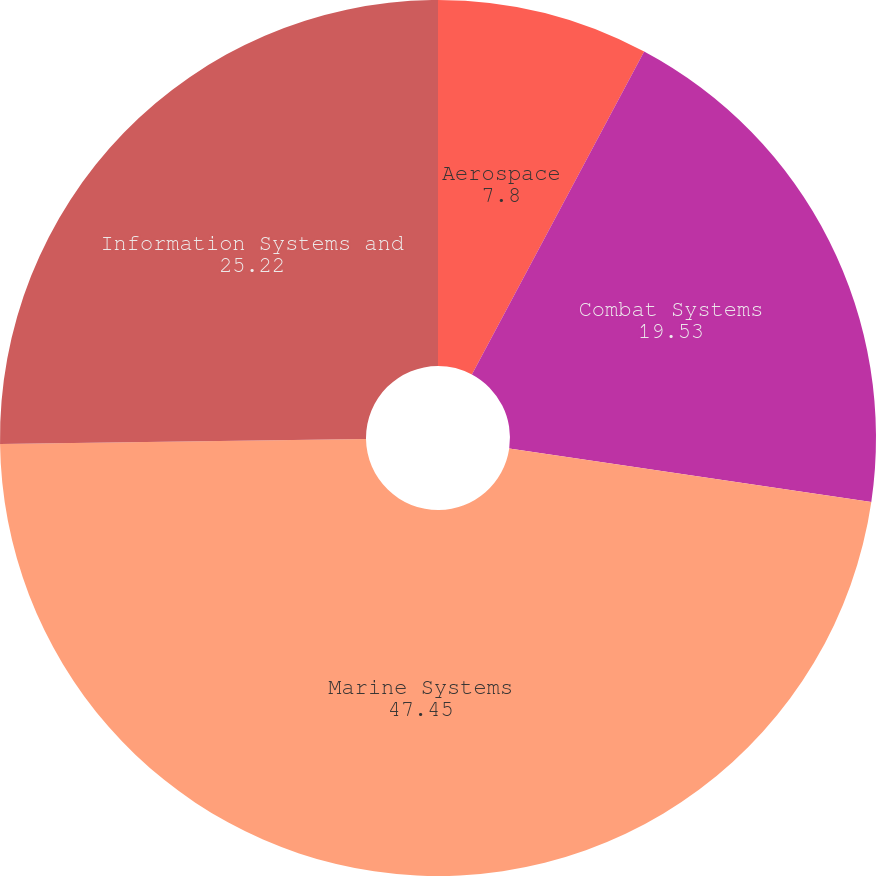Convert chart. <chart><loc_0><loc_0><loc_500><loc_500><pie_chart><fcel>Aerospace<fcel>Combat Systems<fcel>Marine Systems<fcel>Information Systems and<nl><fcel>7.8%<fcel>19.53%<fcel>47.45%<fcel>25.22%<nl></chart> 